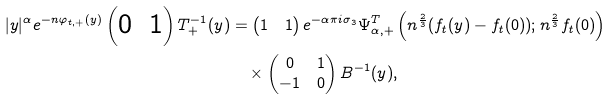Convert formula to latex. <formula><loc_0><loc_0><loc_500><loc_500>| y | ^ { \alpha } e ^ { - n \varphi _ { t , + } ( y ) } \begin{pmatrix} 0 & 1 \end{pmatrix} T _ { + } ^ { - 1 } ( y ) & = \begin{pmatrix} 1 & 1 \end{pmatrix} e ^ { - \alpha \pi i \sigma _ { 3 } } \Psi _ { \alpha , + } ^ { T } \left ( n ^ { \frac { 2 } { 3 } } ( f _ { t } ( y ) - f _ { t } ( 0 ) ) ; n ^ { \frac { 2 } { 3 } } f _ { t } ( 0 ) \right ) \\ & \quad \times \begin{pmatrix} 0 & 1 \\ - 1 & 0 \end{pmatrix} B ^ { - 1 } ( y ) ,</formula> 